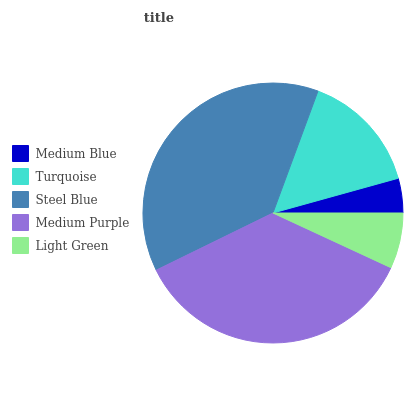Is Medium Blue the minimum?
Answer yes or no. Yes. Is Steel Blue the maximum?
Answer yes or no. Yes. Is Turquoise the minimum?
Answer yes or no. No. Is Turquoise the maximum?
Answer yes or no. No. Is Turquoise greater than Medium Blue?
Answer yes or no. Yes. Is Medium Blue less than Turquoise?
Answer yes or no. Yes. Is Medium Blue greater than Turquoise?
Answer yes or no. No. Is Turquoise less than Medium Blue?
Answer yes or no. No. Is Turquoise the high median?
Answer yes or no. Yes. Is Turquoise the low median?
Answer yes or no. Yes. Is Medium Blue the high median?
Answer yes or no. No. Is Medium Blue the low median?
Answer yes or no. No. 